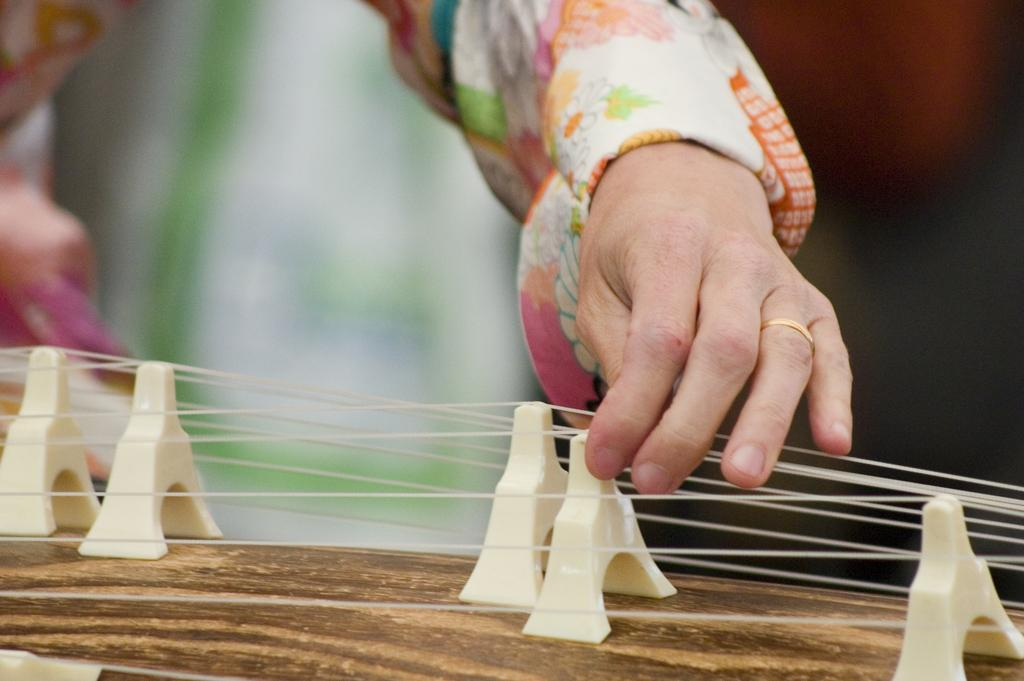What is the main subject of the image? There is a person in the image. What is the person doing in the image? The person is tying ropes. What are the ropes being tied to? The ropes are being tied to similar objects. Can you describe the surface on which the objects are placed? The objects are on a wooden plank. What type of linen is being used to tie the ropes in the image? There is no mention of linen in the image; the ropes are being tied directly to the objects. How is the wooden plank being oiled in the image? There is no mention of oiling the wooden plank in the image; the focus is on the person tying ropes to similar objects on the plank. 